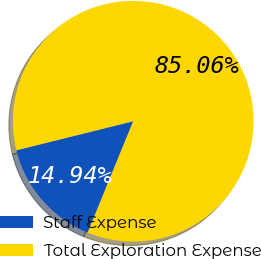Convert chart. <chart><loc_0><loc_0><loc_500><loc_500><pie_chart><fcel>Staff Expense<fcel>Total Exploration Expense<nl><fcel>14.94%<fcel>85.06%<nl></chart> 